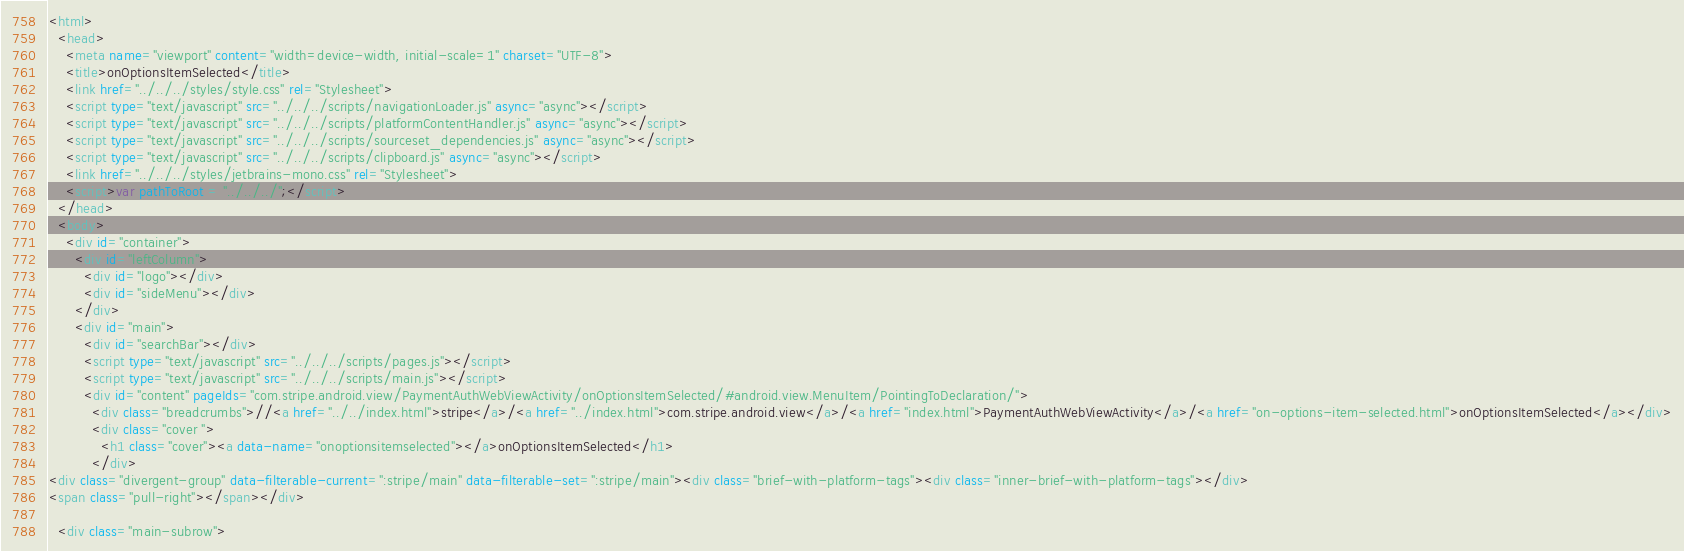<code> <loc_0><loc_0><loc_500><loc_500><_HTML_><html>
  <head>
    <meta name="viewport" content="width=device-width, initial-scale=1" charset="UTF-8">
    <title>onOptionsItemSelected</title>
    <link href="../../../styles/style.css" rel="Stylesheet">
    <script type="text/javascript" src="../../../scripts/navigationLoader.js" async="async"></script>
    <script type="text/javascript" src="../../../scripts/platformContentHandler.js" async="async"></script>
    <script type="text/javascript" src="../../../scripts/sourceset_dependencies.js" async="async"></script>
    <script type="text/javascript" src="../../../scripts/clipboard.js" async="async"></script>
    <link href="../../../styles/jetbrains-mono.css" rel="Stylesheet">
    <script>var pathToRoot = "../../../";</script>
  </head>
  <body>
    <div id="container">
      <div id="leftColumn">
        <div id="logo"></div>
        <div id="sideMenu"></div>
      </div>
      <div id="main">
        <div id="searchBar"></div>
        <script type="text/javascript" src="../../../scripts/pages.js"></script>
        <script type="text/javascript" src="../../../scripts/main.js"></script>
        <div id="content" pageIds="com.stripe.android.view/PaymentAuthWebViewActivity/onOptionsItemSelected/#android.view.MenuItem/PointingToDeclaration/">
          <div class="breadcrumbs">//<a href="../../index.html">stripe</a>/<a href="../index.html">com.stripe.android.view</a>/<a href="index.html">PaymentAuthWebViewActivity</a>/<a href="on-options-item-selected.html">onOptionsItemSelected</a></div>
          <div class="cover ">
            <h1 class="cover"><a data-name="onoptionsitemselected"></a>onOptionsItemSelected</h1>
          </div>
<div class="divergent-group" data-filterable-current=":stripe/main" data-filterable-set=":stripe/main"><div class="brief-with-platform-tags"><div class="inner-brief-with-platform-tags"></div>
<span class="pull-right"></span></div>

  <div class="main-subrow"></code> 